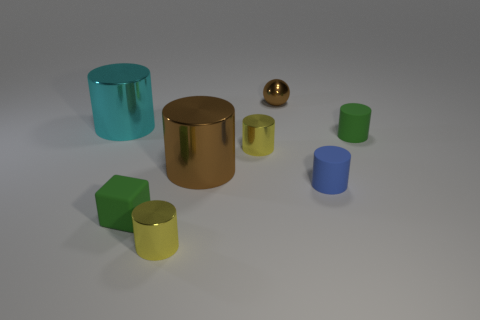Subtract 3 cylinders. How many cylinders are left? 3 Subtract all brown metallic cylinders. How many cylinders are left? 5 Subtract all cyan cylinders. How many cylinders are left? 5 Subtract all gray cylinders. Subtract all red blocks. How many cylinders are left? 6 Add 1 large brown cylinders. How many objects exist? 9 Subtract all balls. How many objects are left? 7 Add 2 tiny green cylinders. How many tiny green cylinders exist? 3 Subtract 0 red cylinders. How many objects are left? 8 Subtract all big purple blocks. Subtract all small green cylinders. How many objects are left? 7 Add 6 small blue matte objects. How many small blue matte objects are left? 7 